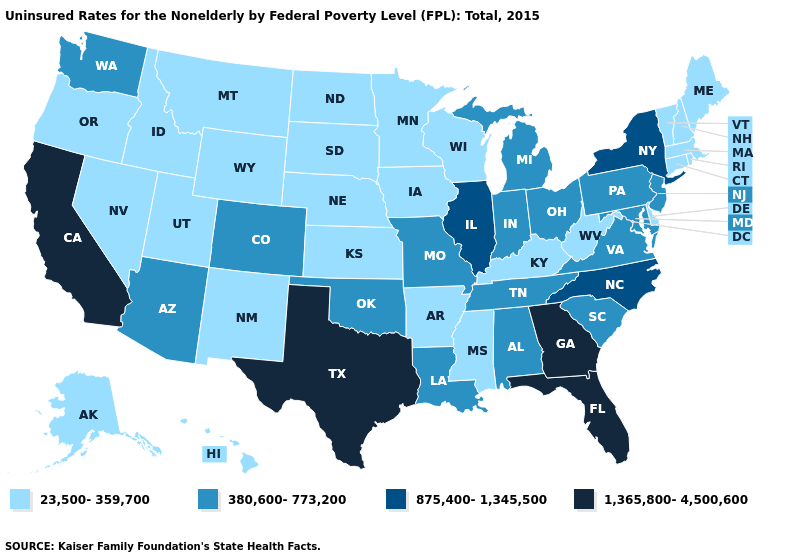Does New Jersey have the lowest value in the Northeast?
Write a very short answer. No. What is the value of Florida?
Answer briefly. 1,365,800-4,500,600. What is the value of California?
Write a very short answer. 1,365,800-4,500,600. Among the states that border Minnesota , which have the highest value?
Concise answer only. Iowa, North Dakota, South Dakota, Wisconsin. Among the states that border Arkansas , which have the lowest value?
Be succinct. Mississippi. What is the value of Nevada?
Keep it brief. 23,500-359,700. What is the lowest value in the USA?
Short answer required. 23,500-359,700. What is the value of California?
Be succinct. 1,365,800-4,500,600. Name the states that have a value in the range 380,600-773,200?
Give a very brief answer. Alabama, Arizona, Colorado, Indiana, Louisiana, Maryland, Michigan, Missouri, New Jersey, Ohio, Oklahoma, Pennsylvania, South Carolina, Tennessee, Virginia, Washington. Name the states that have a value in the range 380,600-773,200?
Give a very brief answer. Alabama, Arizona, Colorado, Indiana, Louisiana, Maryland, Michigan, Missouri, New Jersey, Ohio, Oklahoma, Pennsylvania, South Carolina, Tennessee, Virginia, Washington. Among the states that border Connecticut , which have the highest value?
Concise answer only. New York. What is the lowest value in the USA?
Concise answer only. 23,500-359,700. Which states have the lowest value in the USA?
Be succinct. Alaska, Arkansas, Connecticut, Delaware, Hawaii, Idaho, Iowa, Kansas, Kentucky, Maine, Massachusetts, Minnesota, Mississippi, Montana, Nebraska, Nevada, New Hampshire, New Mexico, North Dakota, Oregon, Rhode Island, South Dakota, Utah, Vermont, West Virginia, Wisconsin, Wyoming. Name the states that have a value in the range 875,400-1,345,500?
Quick response, please. Illinois, New York, North Carolina. 